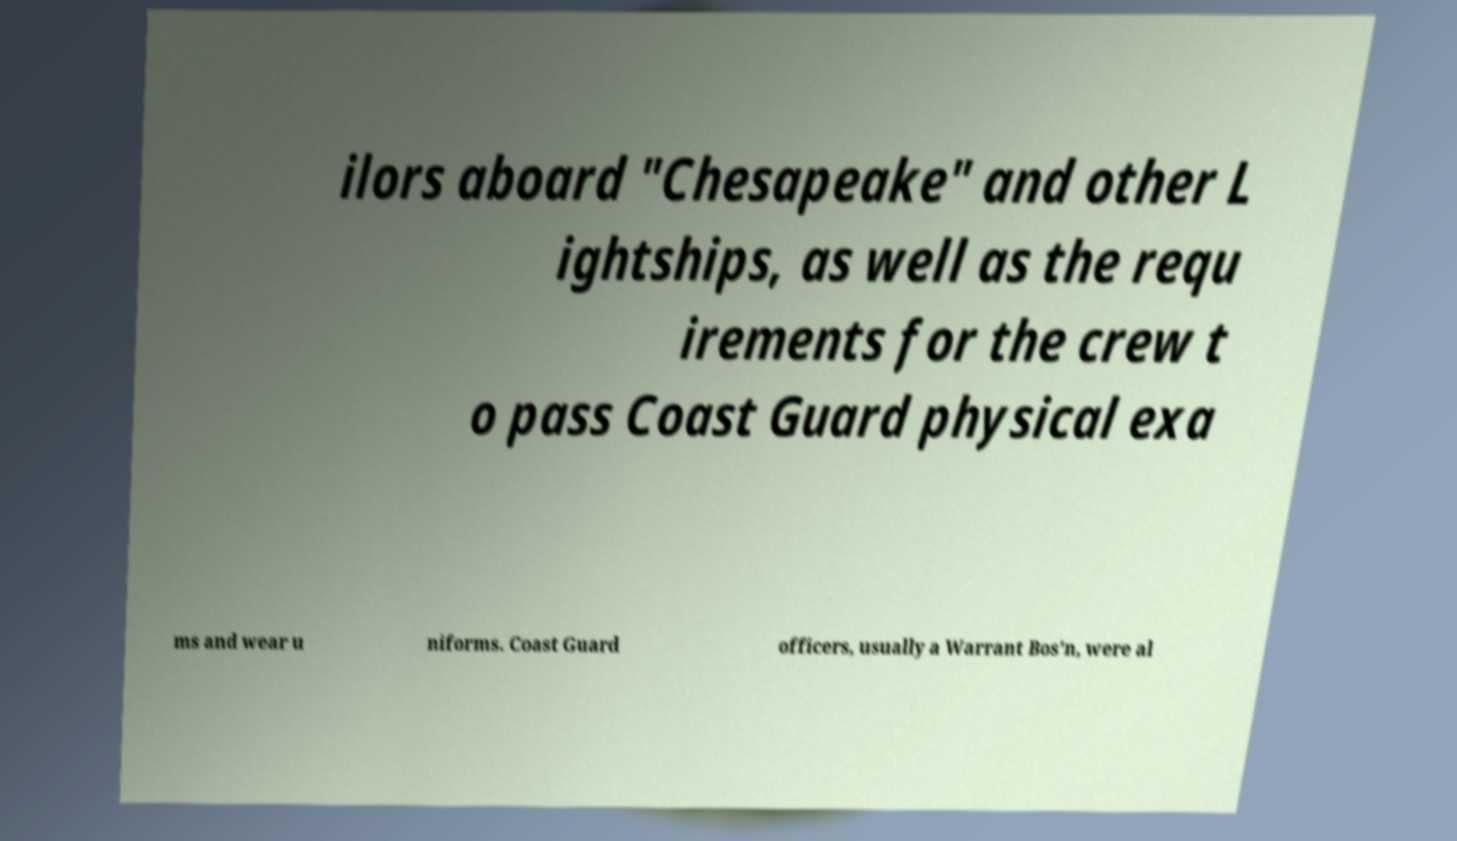Please identify and transcribe the text found in this image. ilors aboard "Chesapeake" and other L ightships, as well as the requ irements for the crew t o pass Coast Guard physical exa ms and wear u niforms. Coast Guard officers, usually a Warrant Bos'n, were al 